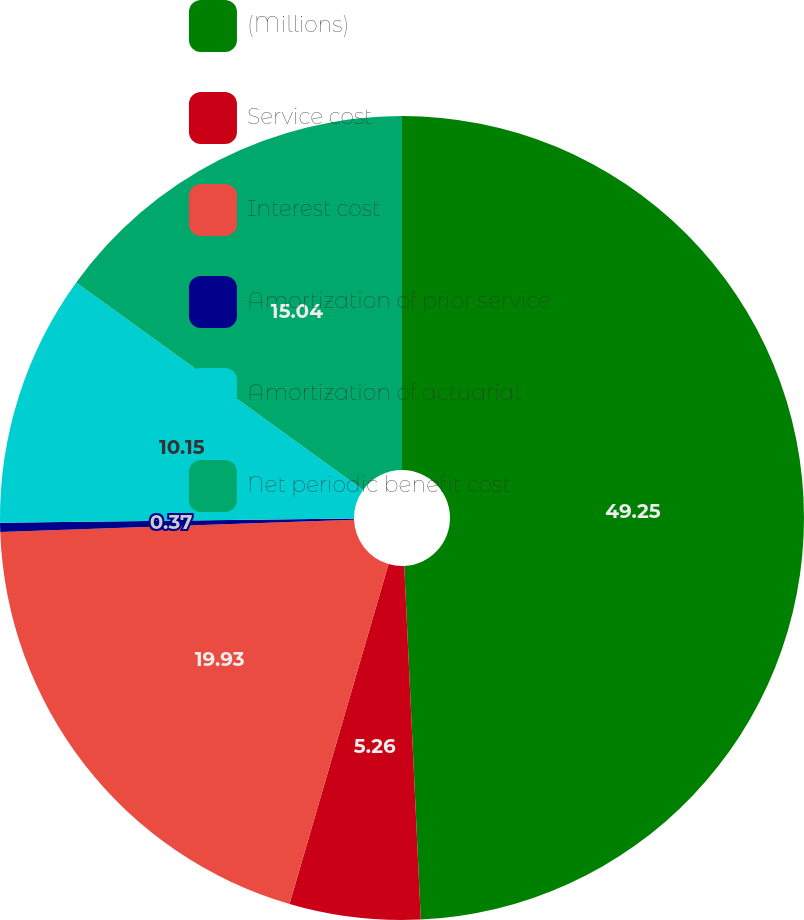<chart> <loc_0><loc_0><loc_500><loc_500><pie_chart><fcel>(Millions)<fcel>Service cost<fcel>Interest cost<fcel>Amortization of prior service<fcel>Amortization of actuarial<fcel>Net periodic benefit cost<nl><fcel>49.26%<fcel>5.26%<fcel>19.93%<fcel>0.37%<fcel>10.15%<fcel>15.04%<nl></chart> 